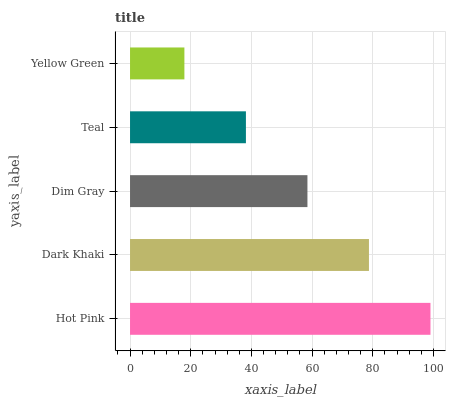Is Yellow Green the minimum?
Answer yes or no. Yes. Is Hot Pink the maximum?
Answer yes or no. Yes. Is Dark Khaki the minimum?
Answer yes or no. No. Is Dark Khaki the maximum?
Answer yes or no. No. Is Hot Pink greater than Dark Khaki?
Answer yes or no. Yes. Is Dark Khaki less than Hot Pink?
Answer yes or no. Yes. Is Dark Khaki greater than Hot Pink?
Answer yes or no. No. Is Hot Pink less than Dark Khaki?
Answer yes or no. No. Is Dim Gray the high median?
Answer yes or no. Yes. Is Dim Gray the low median?
Answer yes or no. Yes. Is Teal the high median?
Answer yes or no. No. Is Teal the low median?
Answer yes or no. No. 